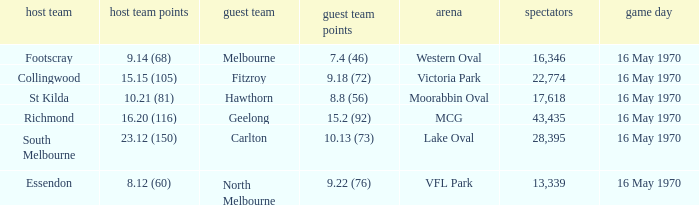Give me the full table as a dictionary. {'header': ['host team', 'host team points', 'guest team', 'guest team points', 'arena', 'spectators', 'game day'], 'rows': [['Footscray', '9.14 (68)', 'Melbourne', '7.4 (46)', 'Western Oval', '16,346', '16 May 1970'], ['Collingwood', '15.15 (105)', 'Fitzroy', '9.18 (72)', 'Victoria Park', '22,774', '16 May 1970'], ['St Kilda', '10.21 (81)', 'Hawthorn', '8.8 (56)', 'Moorabbin Oval', '17,618', '16 May 1970'], ['Richmond', '16.20 (116)', 'Geelong', '15.2 (92)', 'MCG', '43,435', '16 May 1970'], ['South Melbourne', '23.12 (150)', 'Carlton', '10.13 (73)', 'Lake Oval', '28,395', '16 May 1970'], ['Essendon', '8.12 (60)', 'North Melbourne', '9.22 (76)', 'VFL Park', '13,339', '16 May 1970']]} What away team scored 9.18 (72)? Fitzroy. 